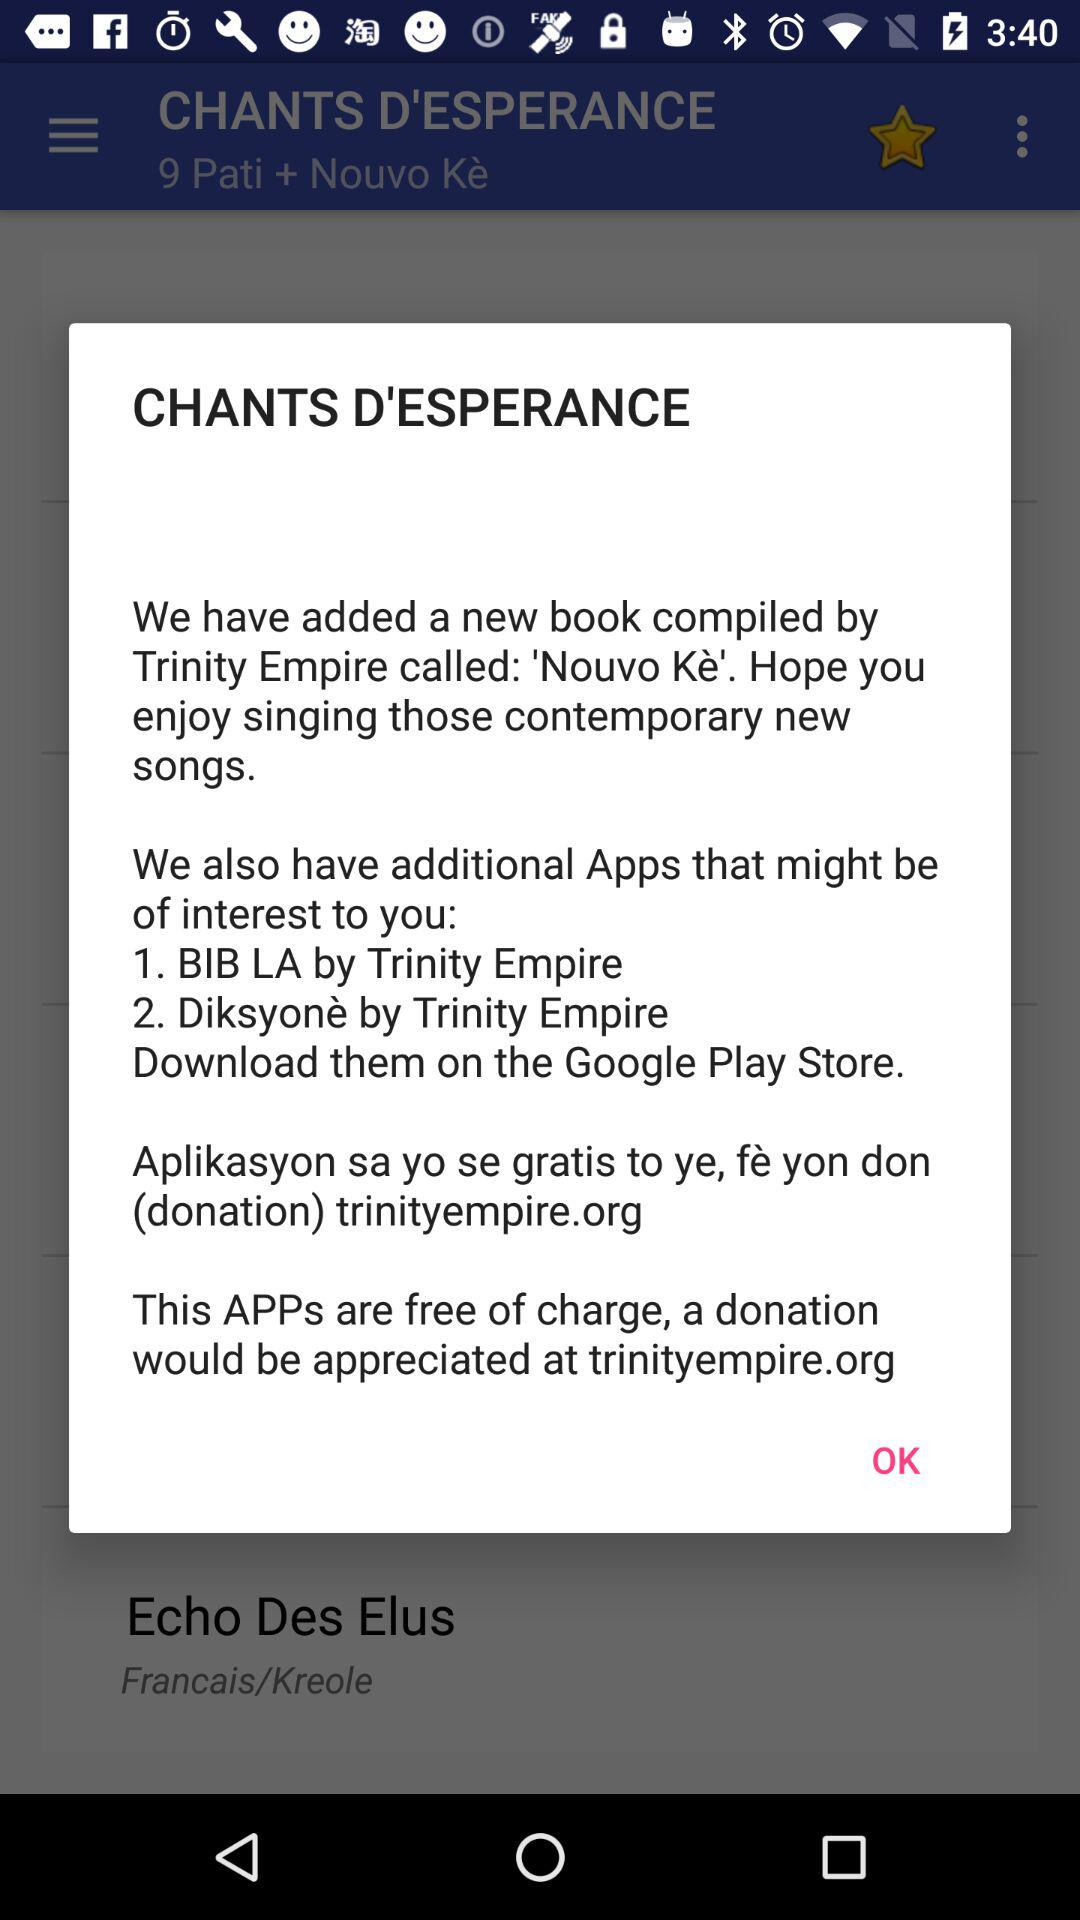How many apps are mentioned in the notification?
Answer the question using a single word or phrase. 2 